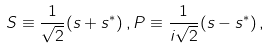<formula> <loc_0><loc_0><loc_500><loc_500>S \equiv \frac { 1 } { \sqrt { 2 } } ( s + s ^ { * } ) \, , P \equiv \frac { 1 } { i \sqrt { 2 } } ( s - s ^ { * } ) \, ,</formula> 